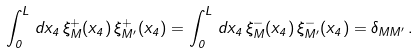Convert formula to latex. <formula><loc_0><loc_0><loc_500><loc_500>\int _ { 0 } ^ { L } \, d x _ { 4 } \, \xi _ { M } ^ { + } ( x _ { 4 } ) \, \xi _ { M ^ { \prime } } ^ { + } ( x _ { 4 } ) = \int _ { 0 } ^ { L } \, d x _ { 4 } \, \xi _ { M } ^ { - } ( x _ { 4 } ) \, \xi _ { M ^ { \prime } } ^ { - } ( x _ { 4 } ) = \delta _ { M M ^ { \prime } } \, .</formula> 